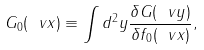<formula> <loc_0><loc_0><loc_500><loc_500>G _ { 0 } ( \ v x ) \equiv \int d ^ { 2 } y \frac { \delta G ( \ v y ) } { \delta f _ { 0 } ( \ v x ) } ,</formula> 